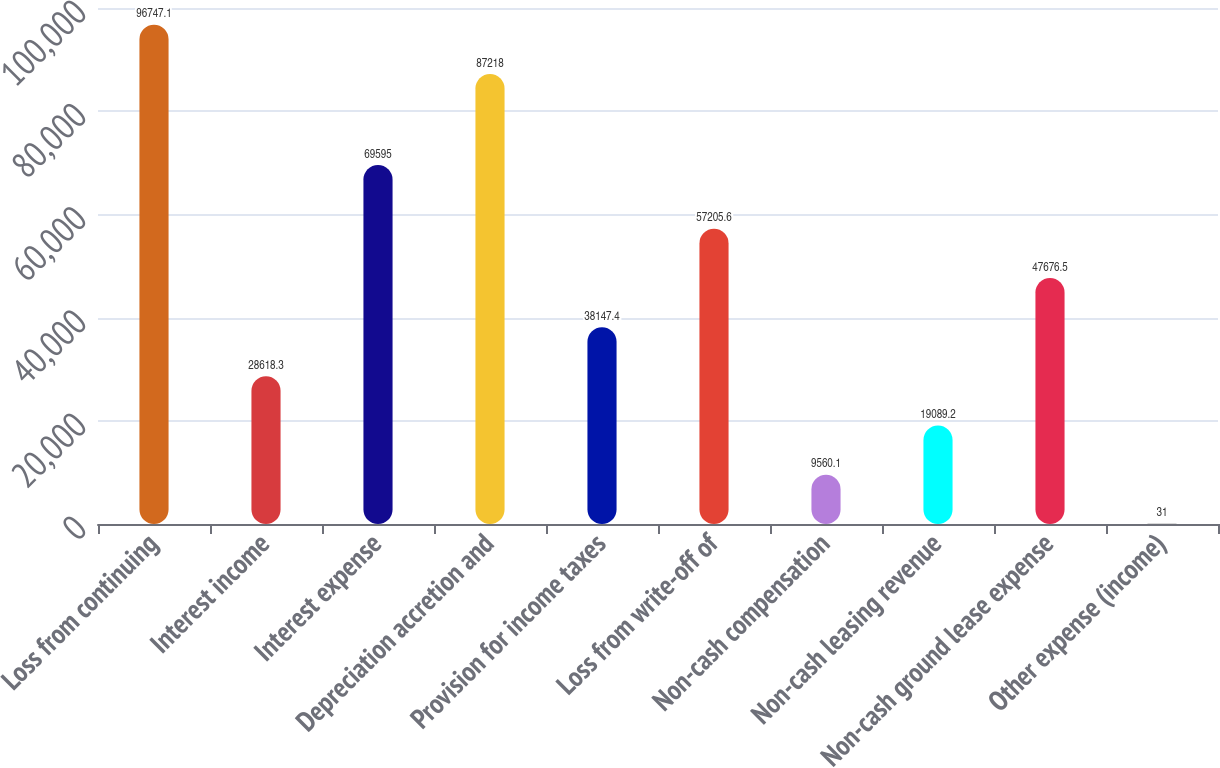Convert chart to OTSL. <chart><loc_0><loc_0><loc_500><loc_500><bar_chart><fcel>Loss from continuing<fcel>Interest income<fcel>Interest expense<fcel>Depreciation accretion and<fcel>Provision for income taxes<fcel>Loss from write-off of<fcel>Non-cash compensation<fcel>Non-cash leasing revenue<fcel>Non-cash ground lease expense<fcel>Other expense (income)<nl><fcel>96747.1<fcel>28618.3<fcel>69595<fcel>87218<fcel>38147.4<fcel>57205.6<fcel>9560.1<fcel>19089.2<fcel>47676.5<fcel>31<nl></chart> 